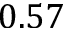<formula> <loc_0><loc_0><loc_500><loc_500>0 . 5 7</formula> 